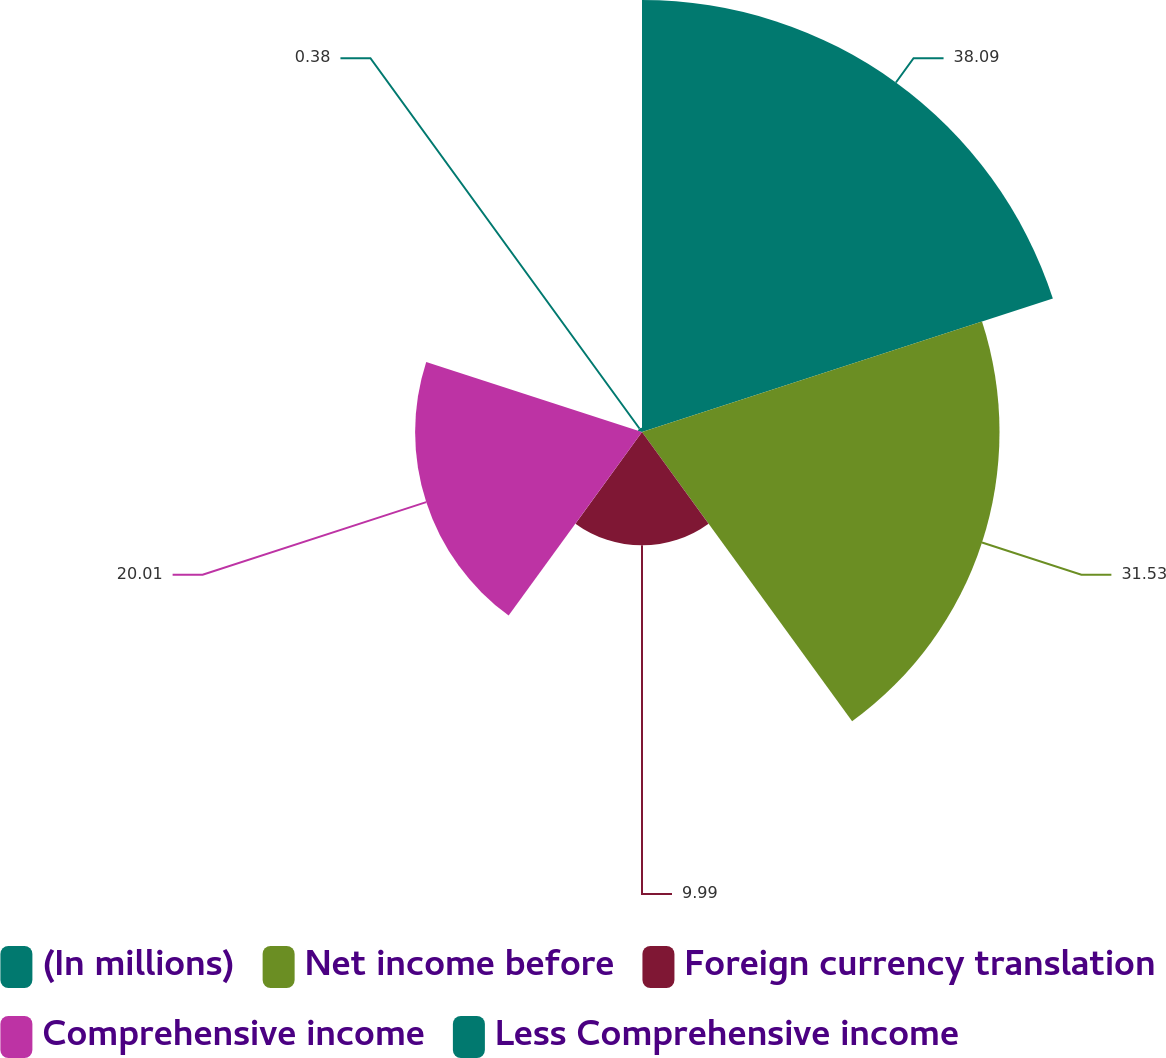Convert chart to OTSL. <chart><loc_0><loc_0><loc_500><loc_500><pie_chart><fcel>(In millions)<fcel>Net income before<fcel>Foreign currency translation<fcel>Comprehensive income<fcel>Less Comprehensive income<nl><fcel>38.1%<fcel>31.53%<fcel>9.99%<fcel>20.01%<fcel>0.38%<nl></chart> 